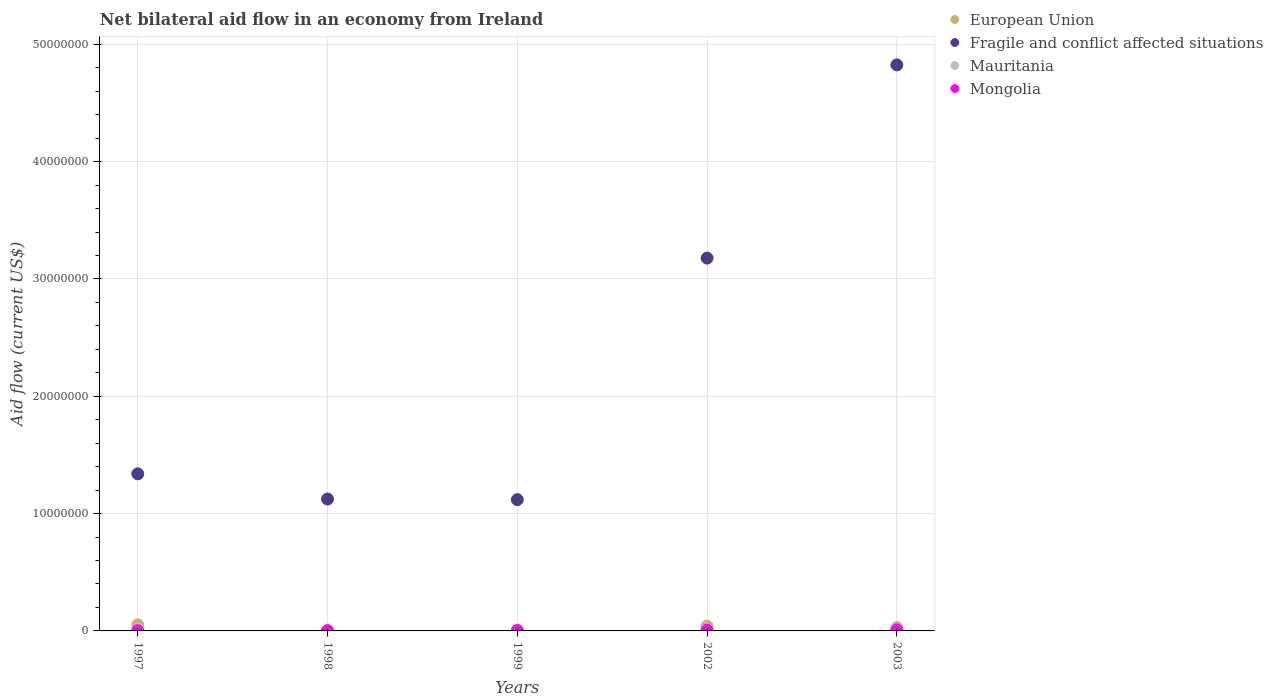Is the number of dotlines equal to the number of legend labels?
Ensure brevity in your answer.  Yes. What is the net bilateral aid flow in Fragile and conflict affected situations in 1997?
Keep it short and to the point. 1.34e+07. In which year was the net bilateral aid flow in European Union minimum?
Make the answer very short. 1998. What is the total net bilateral aid flow in Fragile and conflict affected situations in the graph?
Ensure brevity in your answer.  1.16e+08. What is the difference between the net bilateral aid flow in Mongolia in 1998 and the net bilateral aid flow in Fragile and conflict affected situations in 2003?
Give a very brief answer. -4.82e+07. What is the average net bilateral aid flow in Fragile and conflict affected situations per year?
Ensure brevity in your answer.  2.32e+07. In the year 1999, what is the difference between the net bilateral aid flow in Fragile and conflict affected situations and net bilateral aid flow in Mongolia?
Provide a short and direct response. 1.12e+07. In how many years, is the net bilateral aid flow in Mongolia greater than 24000000 US$?
Keep it short and to the point. 0. What is the ratio of the net bilateral aid flow in Mongolia in 1998 to that in 1999?
Provide a succinct answer. 0.67. Is the difference between the net bilateral aid flow in Fragile and conflict affected situations in 1997 and 1999 greater than the difference between the net bilateral aid flow in Mongolia in 1997 and 1999?
Make the answer very short. Yes. What is the difference between the highest and the second highest net bilateral aid flow in European Union?
Your answer should be very brief. 1.10e+05. Is the sum of the net bilateral aid flow in Mauritania in 1998 and 2003 greater than the maximum net bilateral aid flow in Fragile and conflict affected situations across all years?
Give a very brief answer. No. Is it the case that in every year, the sum of the net bilateral aid flow in European Union and net bilateral aid flow in Fragile and conflict affected situations  is greater than the net bilateral aid flow in Mauritania?
Your answer should be compact. Yes. Is the net bilateral aid flow in European Union strictly greater than the net bilateral aid flow in Fragile and conflict affected situations over the years?
Make the answer very short. No. How many dotlines are there?
Your response must be concise. 4. How many years are there in the graph?
Your answer should be compact. 5. Are the values on the major ticks of Y-axis written in scientific E-notation?
Your answer should be compact. No. Where does the legend appear in the graph?
Your response must be concise. Top right. How many legend labels are there?
Your answer should be very brief. 4. How are the legend labels stacked?
Give a very brief answer. Vertical. What is the title of the graph?
Keep it short and to the point. Net bilateral aid flow in an economy from Ireland. What is the label or title of the Y-axis?
Ensure brevity in your answer.  Aid flow (current US$). What is the Aid flow (current US$) in European Union in 1997?
Keep it short and to the point. 5.20e+05. What is the Aid flow (current US$) of Fragile and conflict affected situations in 1997?
Offer a terse response. 1.34e+07. What is the Aid flow (current US$) of Fragile and conflict affected situations in 1998?
Keep it short and to the point. 1.12e+07. What is the Aid flow (current US$) in Mauritania in 1998?
Provide a succinct answer. 2.00e+04. What is the Aid flow (current US$) of Fragile and conflict affected situations in 1999?
Ensure brevity in your answer.  1.12e+07. What is the Aid flow (current US$) in Mongolia in 1999?
Make the answer very short. 3.00e+04. What is the Aid flow (current US$) in Fragile and conflict affected situations in 2002?
Your answer should be compact. 3.18e+07. What is the Aid flow (current US$) in Mauritania in 2002?
Ensure brevity in your answer.  7.00e+04. What is the Aid flow (current US$) in Mongolia in 2002?
Offer a terse response. 6.00e+04. What is the Aid flow (current US$) of Fragile and conflict affected situations in 2003?
Keep it short and to the point. 4.82e+07. What is the Aid flow (current US$) in Mauritania in 2003?
Provide a short and direct response. 1.20e+05. Across all years, what is the maximum Aid flow (current US$) in European Union?
Ensure brevity in your answer.  5.20e+05. Across all years, what is the maximum Aid flow (current US$) in Fragile and conflict affected situations?
Offer a very short reply. 4.82e+07. Across all years, what is the minimum Aid flow (current US$) of Fragile and conflict affected situations?
Make the answer very short. 1.12e+07. Across all years, what is the minimum Aid flow (current US$) in Mongolia?
Make the answer very short. 2.00e+04. What is the total Aid flow (current US$) in European Union in the graph?
Provide a short and direct response. 1.25e+06. What is the total Aid flow (current US$) of Fragile and conflict affected situations in the graph?
Give a very brief answer. 1.16e+08. What is the total Aid flow (current US$) of Mauritania in the graph?
Make the answer very short. 4.00e+05. What is the difference between the Aid flow (current US$) in European Union in 1997 and that in 1998?
Provide a short and direct response. 5.10e+05. What is the difference between the Aid flow (current US$) in Fragile and conflict affected situations in 1997 and that in 1998?
Keep it short and to the point. 2.15e+06. What is the difference between the Aid flow (current US$) of Fragile and conflict affected situations in 1997 and that in 1999?
Your answer should be compact. 2.20e+06. What is the difference between the Aid flow (current US$) of Mauritania in 1997 and that in 1999?
Give a very brief answer. 7.00e+04. What is the difference between the Aid flow (current US$) of Mongolia in 1997 and that in 1999?
Your answer should be compact. -10000. What is the difference between the Aid flow (current US$) in European Union in 1997 and that in 2002?
Provide a succinct answer. 1.10e+05. What is the difference between the Aid flow (current US$) in Fragile and conflict affected situations in 1997 and that in 2002?
Keep it short and to the point. -1.84e+07. What is the difference between the Aid flow (current US$) in Fragile and conflict affected situations in 1997 and that in 2003?
Make the answer very short. -3.49e+07. What is the difference between the Aid flow (current US$) in Mauritania in 1997 and that in 2003?
Give a very brief answer. 10000. What is the difference between the Aid flow (current US$) of Mongolia in 1997 and that in 2003?
Give a very brief answer. -7.00e+04. What is the difference between the Aid flow (current US$) of European Union in 1998 and that in 1999?
Provide a succinct answer. -2.00e+04. What is the difference between the Aid flow (current US$) of Fragile and conflict affected situations in 1998 and that in 1999?
Your answer should be compact. 5.00e+04. What is the difference between the Aid flow (current US$) of Mauritania in 1998 and that in 1999?
Make the answer very short. -4.00e+04. What is the difference between the Aid flow (current US$) in Mongolia in 1998 and that in 1999?
Keep it short and to the point. -10000. What is the difference between the Aid flow (current US$) of European Union in 1998 and that in 2002?
Your response must be concise. -4.00e+05. What is the difference between the Aid flow (current US$) of Fragile and conflict affected situations in 1998 and that in 2002?
Ensure brevity in your answer.  -2.05e+07. What is the difference between the Aid flow (current US$) in Mauritania in 1998 and that in 2002?
Provide a short and direct response. -5.00e+04. What is the difference between the Aid flow (current US$) in Fragile and conflict affected situations in 1998 and that in 2003?
Ensure brevity in your answer.  -3.70e+07. What is the difference between the Aid flow (current US$) in European Union in 1999 and that in 2002?
Make the answer very short. -3.80e+05. What is the difference between the Aid flow (current US$) in Fragile and conflict affected situations in 1999 and that in 2002?
Offer a terse response. -2.06e+07. What is the difference between the Aid flow (current US$) of Mauritania in 1999 and that in 2002?
Your answer should be compact. -10000. What is the difference between the Aid flow (current US$) of Mongolia in 1999 and that in 2002?
Keep it short and to the point. -3.00e+04. What is the difference between the Aid flow (current US$) in European Union in 1999 and that in 2003?
Ensure brevity in your answer.  -2.50e+05. What is the difference between the Aid flow (current US$) in Fragile and conflict affected situations in 1999 and that in 2003?
Provide a short and direct response. -3.71e+07. What is the difference between the Aid flow (current US$) of Mauritania in 1999 and that in 2003?
Offer a terse response. -6.00e+04. What is the difference between the Aid flow (current US$) of Fragile and conflict affected situations in 2002 and that in 2003?
Provide a succinct answer. -1.65e+07. What is the difference between the Aid flow (current US$) of Mongolia in 2002 and that in 2003?
Make the answer very short. -3.00e+04. What is the difference between the Aid flow (current US$) in European Union in 1997 and the Aid flow (current US$) in Fragile and conflict affected situations in 1998?
Your response must be concise. -1.07e+07. What is the difference between the Aid flow (current US$) of European Union in 1997 and the Aid flow (current US$) of Mauritania in 1998?
Keep it short and to the point. 5.00e+05. What is the difference between the Aid flow (current US$) in European Union in 1997 and the Aid flow (current US$) in Mongolia in 1998?
Make the answer very short. 5.00e+05. What is the difference between the Aid flow (current US$) of Fragile and conflict affected situations in 1997 and the Aid flow (current US$) of Mauritania in 1998?
Ensure brevity in your answer.  1.34e+07. What is the difference between the Aid flow (current US$) of Fragile and conflict affected situations in 1997 and the Aid flow (current US$) of Mongolia in 1998?
Provide a short and direct response. 1.34e+07. What is the difference between the Aid flow (current US$) of European Union in 1997 and the Aid flow (current US$) of Fragile and conflict affected situations in 1999?
Keep it short and to the point. -1.07e+07. What is the difference between the Aid flow (current US$) of European Union in 1997 and the Aid flow (current US$) of Mauritania in 1999?
Ensure brevity in your answer.  4.60e+05. What is the difference between the Aid flow (current US$) in Fragile and conflict affected situations in 1997 and the Aid flow (current US$) in Mauritania in 1999?
Offer a very short reply. 1.33e+07. What is the difference between the Aid flow (current US$) of Fragile and conflict affected situations in 1997 and the Aid flow (current US$) of Mongolia in 1999?
Your answer should be compact. 1.34e+07. What is the difference between the Aid flow (current US$) of Mauritania in 1997 and the Aid flow (current US$) of Mongolia in 1999?
Your answer should be compact. 1.00e+05. What is the difference between the Aid flow (current US$) of European Union in 1997 and the Aid flow (current US$) of Fragile and conflict affected situations in 2002?
Give a very brief answer. -3.13e+07. What is the difference between the Aid flow (current US$) in European Union in 1997 and the Aid flow (current US$) in Mauritania in 2002?
Offer a very short reply. 4.50e+05. What is the difference between the Aid flow (current US$) of Fragile and conflict affected situations in 1997 and the Aid flow (current US$) of Mauritania in 2002?
Your answer should be very brief. 1.33e+07. What is the difference between the Aid flow (current US$) in Fragile and conflict affected situations in 1997 and the Aid flow (current US$) in Mongolia in 2002?
Ensure brevity in your answer.  1.33e+07. What is the difference between the Aid flow (current US$) of European Union in 1997 and the Aid flow (current US$) of Fragile and conflict affected situations in 2003?
Offer a terse response. -4.77e+07. What is the difference between the Aid flow (current US$) in European Union in 1997 and the Aid flow (current US$) in Mauritania in 2003?
Your response must be concise. 4.00e+05. What is the difference between the Aid flow (current US$) in European Union in 1997 and the Aid flow (current US$) in Mongolia in 2003?
Offer a terse response. 4.30e+05. What is the difference between the Aid flow (current US$) in Fragile and conflict affected situations in 1997 and the Aid flow (current US$) in Mauritania in 2003?
Give a very brief answer. 1.33e+07. What is the difference between the Aid flow (current US$) in Fragile and conflict affected situations in 1997 and the Aid flow (current US$) in Mongolia in 2003?
Provide a succinct answer. 1.33e+07. What is the difference between the Aid flow (current US$) in European Union in 1998 and the Aid flow (current US$) in Fragile and conflict affected situations in 1999?
Make the answer very short. -1.12e+07. What is the difference between the Aid flow (current US$) in European Union in 1998 and the Aid flow (current US$) in Mauritania in 1999?
Keep it short and to the point. -5.00e+04. What is the difference between the Aid flow (current US$) of European Union in 1998 and the Aid flow (current US$) of Mongolia in 1999?
Your answer should be compact. -2.00e+04. What is the difference between the Aid flow (current US$) in Fragile and conflict affected situations in 1998 and the Aid flow (current US$) in Mauritania in 1999?
Ensure brevity in your answer.  1.12e+07. What is the difference between the Aid flow (current US$) in Fragile and conflict affected situations in 1998 and the Aid flow (current US$) in Mongolia in 1999?
Ensure brevity in your answer.  1.12e+07. What is the difference between the Aid flow (current US$) in European Union in 1998 and the Aid flow (current US$) in Fragile and conflict affected situations in 2002?
Give a very brief answer. -3.18e+07. What is the difference between the Aid flow (current US$) of Fragile and conflict affected situations in 1998 and the Aid flow (current US$) of Mauritania in 2002?
Keep it short and to the point. 1.12e+07. What is the difference between the Aid flow (current US$) in Fragile and conflict affected situations in 1998 and the Aid flow (current US$) in Mongolia in 2002?
Keep it short and to the point. 1.12e+07. What is the difference between the Aid flow (current US$) of Mauritania in 1998 and the Aid flow (current US$) of Mongolia in 2002?
Ensure brevity in your answer.  -4.00e+04. What is the difference between the Aid flow (current US$) in European Union in 1998 and the Aid flow (current US$) in Fragile and conflict affected situations in 2003?
Offer a terse response. -4.82e+07. What is the difference between the Aid flow (current US$) of Fragile and conflict affected situations in 1998 and the Aid flow (current US$) of Mauritania in 2003?
Your answer should be compact. 1.11e+07. What is the difference between the Aid flow (current US$) in Fragile and conflict affected situations in 1998 and the Aid flow (current US$) in Mongolia in 2003?
Your response must be concise. 1.12e+07. What is the difference between the Aid flow (current US$) of Mauritania in 1998 and the Aid flow (current US$) of Mongolia in 2003?
Ensure brevity in your answer.  -7.00e+04. What is the difference between the Aid flow (current US$) in European Union in 1999 and the Aid flow (current US$) in Fragile and conflict affected situations in 2002?
Make the answer very short. -3.18e+07. What is the difference between the Aid flow (current US$) of European Union in 1999 and the Aid flow (current US$) of Mongolia in 2002?
Keep it short and to the point. -3.00e+04. What is the difference between the Aid flow (current US$) of Fragile and conflict affected situations in 1999 and the Aid flow (current US$) of Mauritania in 2002?
Your response must be concise. 1.11e+07. What is the difference between the Aid flow (current US$) of Fragile and conflict affected situations in 1999 and the Aid flow (current US$) of Mongolia in 2002?
Keep it short and to the point. 1.11e+07. What is the difference between the Aid flow (current US$) in European Union in 1999 and the Aid flow (current US$) in Fragile and conflict affected situations in 2003?
Your answer should be very brief. -4.82e+07. What is the difference between the Aid flow (current US$) in European Union in 1999 and the Aid flow (current US$) in Mongolia in 2003?
Ensure brevity in your answer.  -6.00e+04. What is the difference between the Aid flow (current US$) of Fragile and conflict affected situations in 1999 and the Aid flow (current US$) of Mauritania in 2003?
Provide a short and direct response. 1.11e+07. What is the difference between the Aid flow (current US$) of Fragile and conflict affected situations in 1999 and the Aid flow (current US$) of Mongolia in 2003?
Offer a very short reply. 1.11e+07. What is the difference between the Aid flow (current US$) in European Union in 2002 and the Aid flow (current US$) in Fragile and conflict affected situations in 2003?
Offer a terse response. -4.78e+07. What is the difference between the Aid flow (current US$) of European Union in 2002 and the Aid flow (current US$) of Mauritania in 2003?
Provide a short and direct response. 2.90e+05. What is the difference between the Aid flow (current US$) of Fragile and conflict affected situations in 2002 and the Aid flow (current US$) of Mauritania in 2003?
Offer a very short reply. 3.17e+07. What is the difference between the Aid flow (current US$) in Fragile and conflict affected situations in 2002 and the Aid flow (current US$) in Mongolia in 2003?
Your answer should be compact. 3.17e+07. What is the difference between the Aid flow (current US$) in Mauritania in 2002 and the Aid flow (current US$) in Mongolia in 2003?
Provide a short and direct response. -2.00e+04. What is the average Aid flow (current US$) in European Union per year?
Your response must be concise. 2.50e+05. What is the average Aid flow (current US$) in Fragile and conflict affected situations per year?
Provide a succinct answer. 2.32e+07. What is the average Aid flow (current US$) in Mongolia per year?
Provide a short and direct response. 4.40e+04. In the year 1997, what is the difference between the Aid flow (current US$) of European Union and Aid flow (current US$) of Fragile and conflict affected situations?
Keep it short and to the point. -1.29e+07. In the year 1997, what is the difference between the Aid flow (current US$) of European Union and Aid flow (current US$) of Mauritania?
Give a very brief answer. 3.90e+05. In the year 1997, what is the difference between the Aid flow (current US$) of Fragile and conflict affected situations and Aid flow (current US$) of Mauritania?
Make the answer very short. 1.33e+07. In the year 1997, what is the difference between the Aid flow (current US$) of Fragile and conflict affected situations and Aid flow (current US$) of Mongolia?
Your answer should be very brief. 1.34e+07. In the year 1998, what is the difference between the Aid flow (current US$) in European Union and Aid flow (current US$) in Fragile and conflict affected situations?
Provide a succinct answer. -1.12e+07. In the year 1998, what is the difference between the Aid flow (current US$) in European Union and Aid flow (current US$) in Mauritania?
Give a very brief answer. -10000. In the year 1998, what is the difference between the Aid flow (current US$) in Fragile and conflict affected situations and Aid flow (current US$) in Mauritania?
Offer a very short reply. 1.12e+07. In the year 1998, what is the difference between the Aid flow (current US$) of Fragile and conflict affected situations and Aid flow (current US$) of Mongolia?
Give a very brief answer. 1.12e+07. In the year 1999, what is the difference between the Aid flow (current US$) of European Union and Aid flow (current US$) of Fragile and conflict affected situations?
Make the answer very short. -1.12e+07. In the year 1999, what is the difference between the Aid flow (current US$) in Fragile and conflict affected situations and Aid flow (current US$) in Mauritania?
Give a very brief answer. 1.11e+07. In the year 1999, what is the difference between the Aid flow (current US$) in Fragile and conflict affected situations and Aid flow (current US$) in Mongolia?
Your answer should be compact. 1.12e+07. In the year 1999, what is the difference between the Aid flow (current US$) of Mauritania and Aid flow (current US$) of Mongolia?
Provide a succinct answer. 3.00e+04. In the year 2002, what is the difference between the Aid flow (current US$) of European Union and Aid flow (current US$) of Fragile and conflict affected situations?
Ensure brevity in your answer.  -3.14e+07. In the year 2002, what is the difference between the Aid flow (current US$) of Fragile and conflict affected situations and Aid flow (current US$) of Mauritania?
Your answer should be compact. 3.17e+07. In the year 2002, what is the difference between the Aid flow (current US$) in Fragile and conflict affected situations and Aid flow (current US$) in Mongolia?
Ensure brevity in your answer.  3.17e+07. In the year 2003, what is the difference between the Aid flow (current US$) of European Union and Aid flow (current US$) of Fragile and conflict affected situations?
Provide a succinct answer. -4.80e+07. In the year 2003, what is the difference between the Aid flow (current US$) of European Union and Aid flow (current US$) of Mauritania?
Your answer should be very brief. 1.60e+05. In the year 2003, what is the difference between the Aid flow (current US$) of European Union and Aid flow (current US$) of Mongolia?
Make the answer very short. 1.90e+05. In the year 2003, what is the difference between the Aid flow (current US$) of Fragile and conflict affected situations and Aid flow (current US$) of Mauritania?
Offer a terse response. 4.81e+07. In the year 2003, what is the difference between the Aid flow (current US$) in Fragile and conflict affected situations and Aid flow (current US$) in Mongolia?
Make the answer very short. 4.82e+07. What is the ratio of the Aid flow (current US$) in European Union in 1997 to that in 1998?
Ensure brevity in your answer.  52. What is the ratio of the Aid flow (current US$) in Fragile and conflict affected situations in 1997 to that in 1998?
Your answer should be compact. 1.19. What is the ratio of the Aid flow (current US$) of Mauritania in 1997 to that in 1998?
Your response must be concise. 6.5. What is the ratio of the Aid flow (current US$) in Mongolia in 1997 to that in 1998?
Make the answer very short. 1. What is the ratio of the Aid flow (current US$) of European Union in 1997 to that in 1999?
Give a very brief answer. 17.33. What is the ratio of the Aid flow (current US$) in Fragile and conflict affected situations in 1997 to that in 1999?
Your answer should be compact. 1.2. What is the ratio of the Aid flow (current US$) of Mauritania in 1997 to that in 1999?
Keep it short and to the point. 2.17. What is the ratio of the Aid flow (current US$) in European Union in 1997 to that in 2002?
Your response must be concise. 1.27. What is the ratio of the Aid flow (current US$) of Fragile and conflict affected situations in 1997 to that in 2002?
Give a very brief answer. 0.42. What is the ratio of the Aid flow (current US$) of Mauritania in 1997 to that in 2002?
Provide a succinct answer. 1.86. What is the ratio of the Aid flow (current US$) in Mongolia in 1997 to that in 2002?
Give a very brief answer. 0.33. What is the ratio of the Aid flow (current US$) of European Union in 1997 to that in 2003?
Provide a succinct answer. 1.86. What is the ratio of the Aid flow (current US$) of Fragile and conflict affected situations in 1997 to that in 2003?
Provide a succinct answer. 0.28. What is the ratio of the Aid flow (current US$) in Mauritania in 1997 to that in 2003?
Make the answer very short. 1.08. What is the ratio of the Aid flow (current US$) in Mongolia in 1997 to that in 2003?
Your answer should be compact. 0.22. What is the ratio of the Aid flow (current US$) in European Union in 1998 to that in 2002?
Provide a succinct answer. 0.02. What is the ratio of the Aid flow (current US$) of Fragile and conflict affected situations in 1998 to that in 2002?
Keep it short and to the point. 0.35. What is the ratio of the Aid flow (current US$) in Mauritania in 1998 to that in 2002?
Your response must be concise. 0.29. What is the ratio of the Aid flow (current US$) of European Union in 1998 to that in 2003?
Your answer should be compact. 0.04. What is the ratio of the Aid flow (current US$) of Fragile and conflict affected situations in 1998 to that in 2003?
Your answer should be very brief. 0.23. What is the ratio of the Aid flow (current US$) in Mauritania in 1998 to that in 2003?
Keep it short and to the point. 0.17. What is the ratio of the Aid flow (current US$) in Mongolia in 1998 to that in 2003?
Offer a very short reply. 0.22. What is the ratio of the Aid flow (current US$) in European Union in 1999 to that in 2002?
Your answer should be very brief. 0.07. What is the ratio of the Aid flow (current US$) in Fragile and conflict affected situations in 1999 to that in 2002?
Give a very brief answer. 0.35. What is the ratio of the Aid flow (current US$) in Mauritania in 1999 to that in 2002?
Provide a short and direct response. 0.86. What is the ratio of the Aid flow (current US$) in Mongolia in 1999 to that in 2002?
Keep it short and to the point. 0.5. What is the ratio of the Aid flow (current US$) of European Union in 1999 to that in 2003?
Your response must be concise. 0.11. What is the ratio of the Aid flow (current US$) in Fragile and conflict affected situations in 1999 to that in 2003?
Offer a terse response. 0.23. What is the ratio of the Aid flow (current US$) of Mauritania in 1999 to that in 2003?
Ensure brevity in your answer.  0.5. What is the ratio of the Aid flow (current US$) in European Union in 2002 to that in 2003?
Offer a terse response. 1.46. What is the ratio of the Aid flow (current US$) of Fragile and conflict affected situations in 2002 to that in 2003?
Offer a terse response. 0.66. What is the ratio of the Aid flow (current US$) of Mauritania in 2002 to that in 2003?
Provide a short and direct response. 0.58. What is the difference between the highest and the second highest Aid flow (current US$) in Fragile and conflict affected situations?
Offer a very short reply. 1.65e+07. What is the difference between the highest and the lowest Aid flow (current US$) in European Union?
Keep it short and to the point. 5.10e+05. What is the difference between the highest and the lowest Aid flow (current US$) of Fragile and conflict affected situations?
Your answer should be compact. 3.71e+07. What is the difference between the highest and the lowest Aid flow (current US$) in Mongolia?
Make the answer very short. 7.00e+04. 